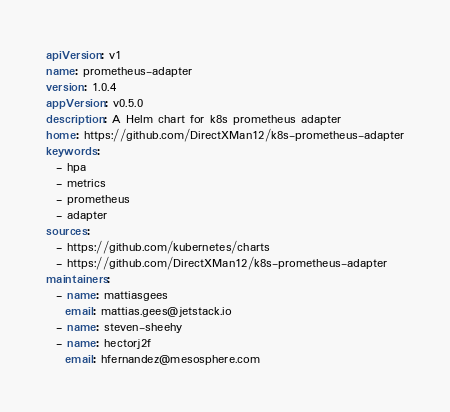<code> <loc_0><loc_0><loc_500><loc_500><_YAML_>apiVersion: v1
name: prometheus-adapter
version: 1.0.4
appVersion: v0.5.0
description: A Helm chart for k8s prometheus adapter
home: https://github.com/DirectXMan12/k8s-prometheus-adapter
keywords:
  - hpa
  - metrics
  - prometheus
  - adapter
sources:
  - https://github.com/kubernetes/charts
  - https://github.com/DirectXMan12/k8s-prometheus-adapter
maintainers:
  - name: mattiasgees
    email: mattias.gees@jetstack.io
  - name: steven-sheehy
  - name: hectorj2f
    email: hfernandez@mesosphere.com
</code> 